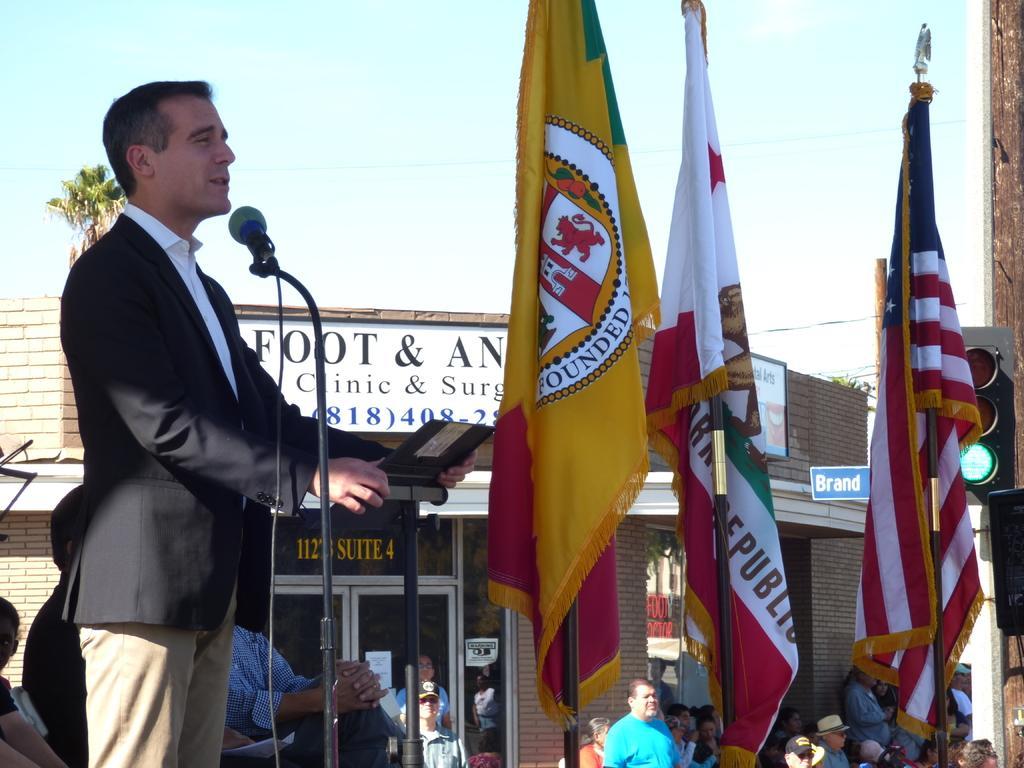In one or two sentences, can you explain what this image depicts? In this image in the center there is a man standing and speaking. There are flags in the front and in the background there are persons. There is a building and there are boards with some text written on it and there is a tree and the sky is cloudy. 